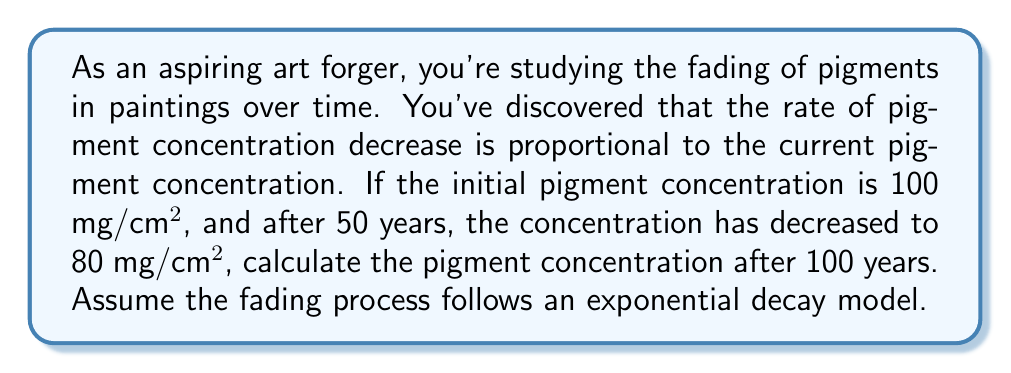Teach me how to tackle this problem. Let's approach this step-by-step:

1) Let $C(t)$ be the pigment concentration at time $t$ in years.

2) The rate of change of concentration is proportional to the current concentration:

   $$\frac{dC}{dt} = -kC$$

   where $k$ is the decay constant.

3) The solution to this differential equation is:

   $$C(t) = C_0e^{-kt}$$

   where $C_0$ is the initial concentration.

4) We know:
   - $C_0 = 100$ mg/cm²
   - $C(50) = 80$ mg/cm²

5) Let's find $k$ using the information at $t = 50$:

   $$80 = 100e^{-50k}$$

6) Solving for $k$:

   $$\ln(0.8) = -50k$$
   $$k = -\frac{\ln(0.8)}{50} \approx 0.00446$$

7) Now we have our full equation:

   $$C(t) = 100e^{-0.00446t}$$

8) To find the concentration at 100 years, we calculate:

   $$C(100) = 100e^{-0.00446(100)} \approx 64.06$$ mg/cm²
Answer: $64.06$ mg/cm² 